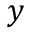<formula> <loc_0><loc_0><loc_500><loc_500>y</formula> 